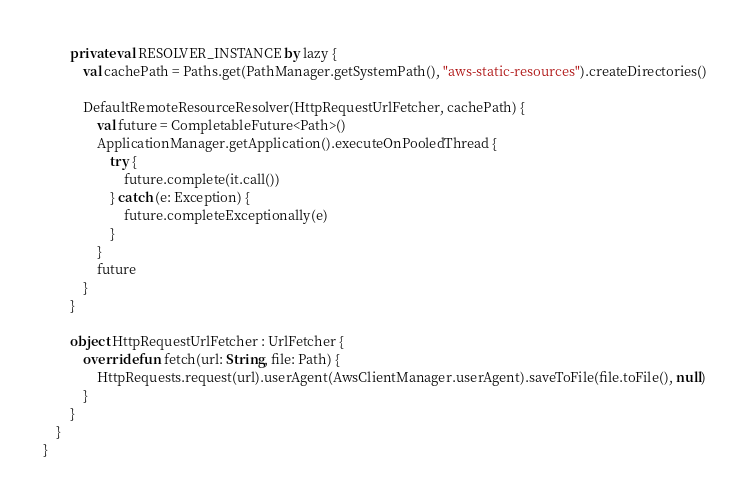Convert code to text. <code><loc_0><loc_0><loc_500><loc_500><_Kotlin_>        private val RESOLVER_INSTANCE by lazy {
            val cachePath = Paths.get(PathManager.getSystemPath(), "aws-static-resources").createDirectories()

            DefaultRemoteResourceResolver(HttpRequestUrlFetcher, cachePath) {
                val future = CompletableFuture<Path>()
                ApplicationManager.getApplication().executeOnPooledThread {
                    try {
                        future.complete(it.call())
                    } catch (e: Exception) {
                        future.completeExceptionally(e)
                    }
                }
                future
            }
        }

        object HttpRequestUrlFetcher : UrlFetcher {
            override fun fetch(url: String, file: Path) {
                HttpRequests.request(url).userAgent(AwsClientManager.userAgent).saveToFile(file.toFile(), null)
            }
        }
    }
}
</code> 